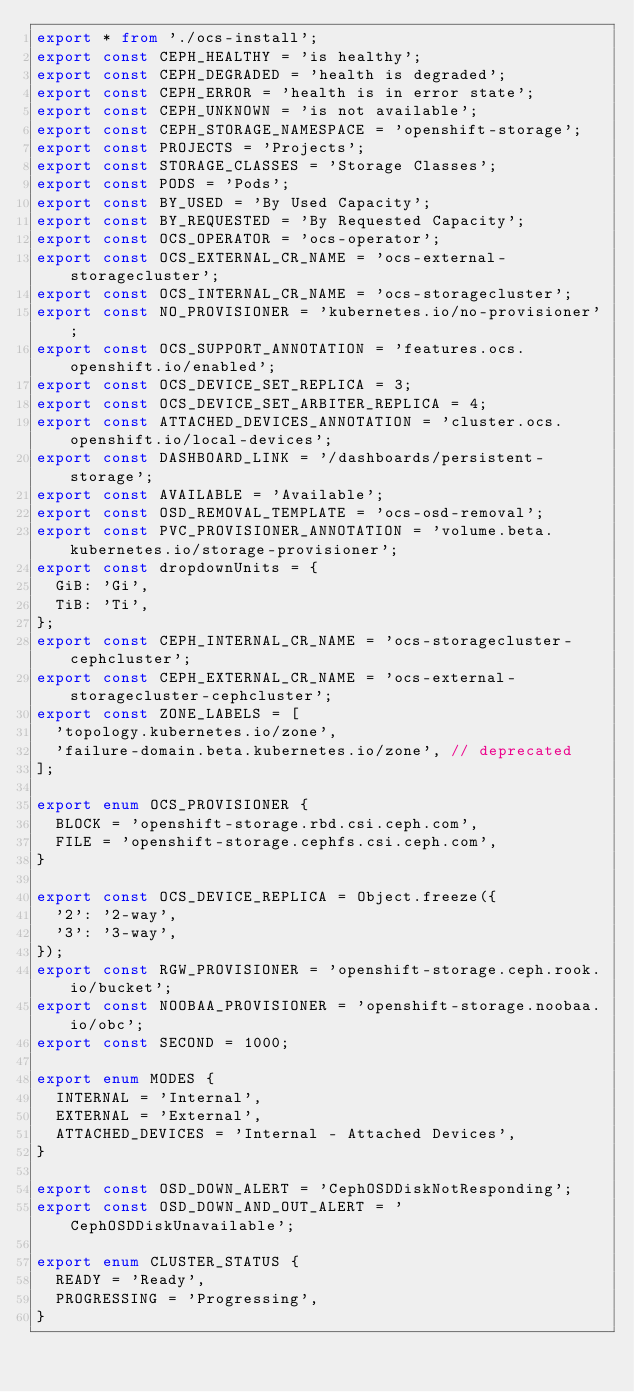Convert code to text. <code><loc_0><loc_0><loc_500><loc_500><_TypeScript_>export * from './ocs-install';
export const CEPH_HEALTHY = 'is healthy';
export const CEPH_DEGRADED = 'health is degraded';
export const CEPH_ERROR = 'health is in error state';
export const CEPH_UNKNOWN = 'is not available';
export const CEPH_STORAGE_NAMESPACE = 'openshift-storage';
export const PROJECTS = 'Projects';
export const STORAGE_CLASSES = 'Storage Classes';
export const PODS = 'Pods';
export const BY_USED = 'By Used Capacity';
export const BY_REQUESTED = 'By Requested Capacity';
export const OCS_OPERATOR = 'ocs-operator';
export const OCS_EXTERNAL_CR_NAME = 'ocs-external-storagecluster';
export const OCS_INTERNAL_CR_NAME = 'ocs-storagecluster';
export const NO_PROVISIONER = 'kubernetes.io/no-provisioner';
export const OCS_SUPPORT_ANNOTATION = 'features.ocs.openshift.io/enabled';
export const OCS_DEVICE_SET_REPLICA = 3;
export const OCS_DEVICE_SET_ARBITER_REPLICA = 4;
export const ATTACHED_DEVICES_ANNOTATION = 'cluster.ocs.openshift.io/local-devices';
export const DASHBOARD_LINK = '/dashboards/persistent-storage';
export const AVAILABLE = 'Available';
export const OSD_REMOVAL_TEMPLATE = 'ocs-osd-removal';
export const PVC_PROVISIONER_ANNOTATION = 'volume.beta.kubernetes.io/storage-provisioner';
export const dropdownUnits = {
  GiB: 'Gi',
  TiB: 'Ti',
};
export const CEPH_INTERNAL_CR_NAME = 'ocs-storagecluster-cephcluster';
export const CEPH_EXTERNAL_CR_NAME = 'ocs-external-storagecluster-cephcluster';
export const ZONE_LABELS = [
  'topology.kubernetes.io/zone',
  'failure-domain.beta.kubernetes.io/zone', // deprecated
];

export enum OCS_PROVISIONER {
  BLOCK = 'openshift-storage.rbd.csi.ceph.com',
  FILE = 'openshift-storage.cephfs.csi.ceph.com',
}

export const OCS_DEVICE_REPLICA = Object.freeze({
  '2': '2-way',
  '3': '3-way',
});
export const RGW_PROVISIONER = 'openshift-storage.ceph.rook.io/bucket';
export const NOOBAA_PROVISIONER = 'openshift-storage.noobaa.io/obc';
export const SECOND = 1000;

export enum MODES {
  INTERNAL = 'Internal',
  EXTERNAL = 'External',
  ATTACHED_DEVICES = 'Internal - Attached Devices',
}

export const OSD_DOWN_ALERT = 'CephOSDDiskNotResponding';
export const OSD_DOWN_AND_OUT_ALERT = 'CephOSDDiskUnavailable';

export enum CLUSTER_STATUS {
  READY = 'Ready',
  PROGRESSING = 'Progressing',
}
</code> 